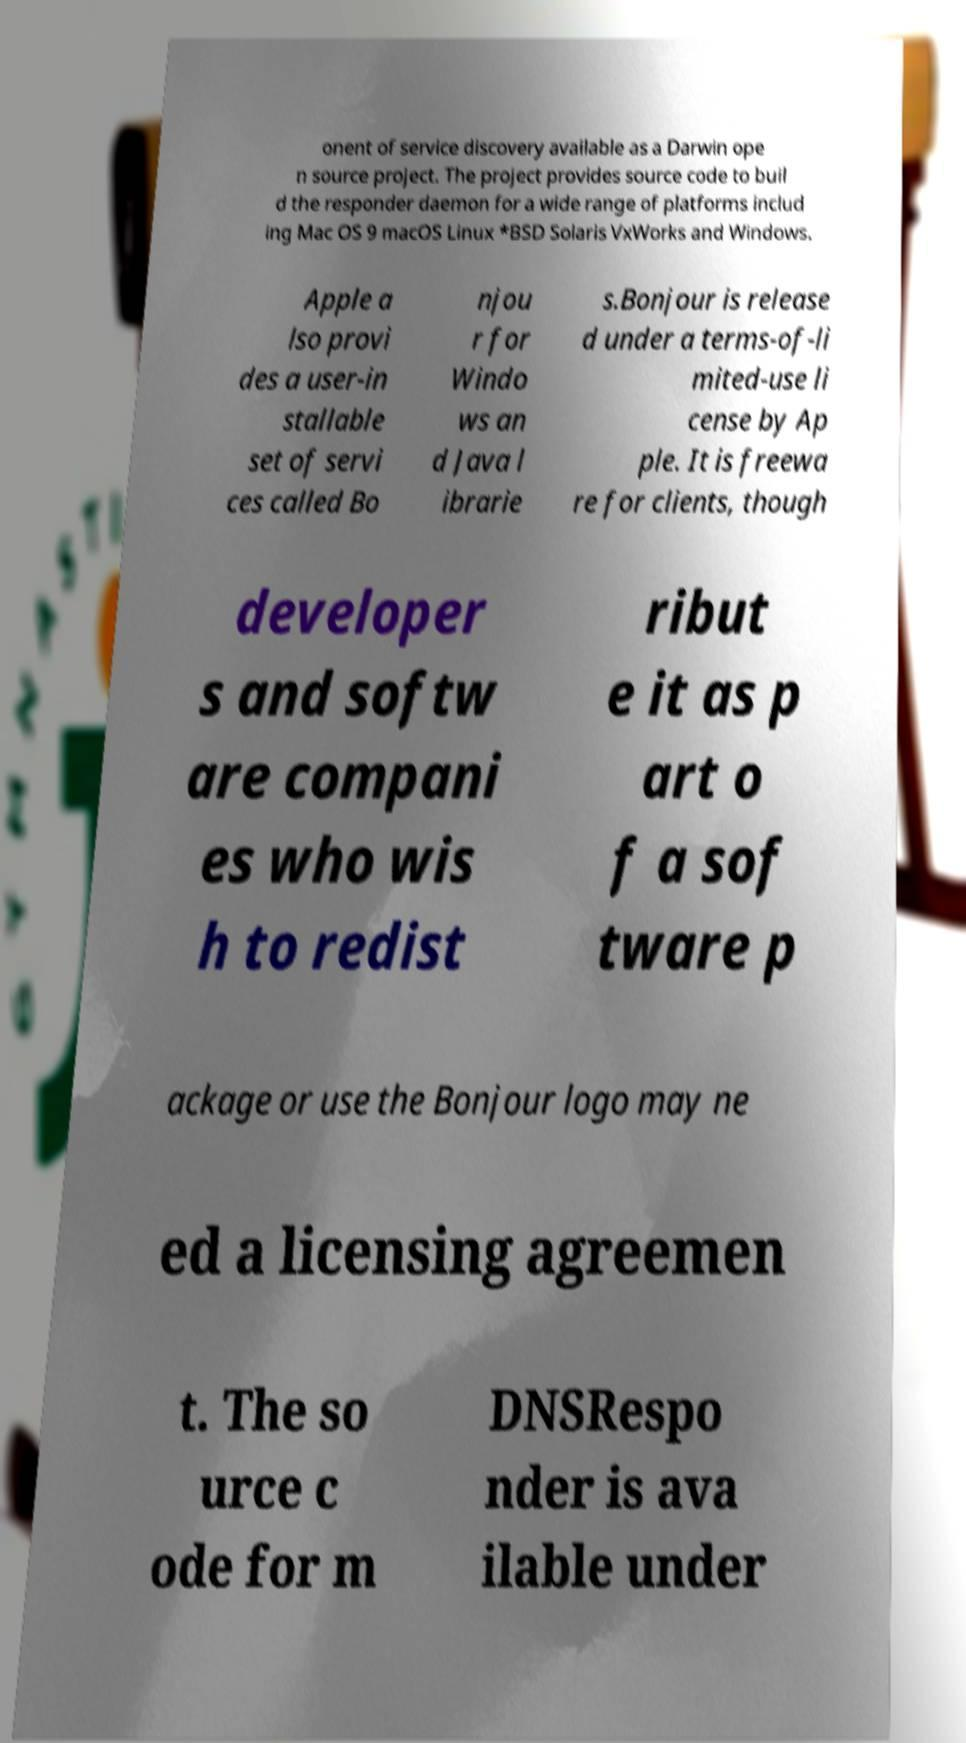Can you read and provide the text displayed in the image?This photo seems to have some interesting text. Can you extract and type it out for me? onent of service discovery available as a Darwin ope n source project. The project provides source code to buil d the responder daemon for a wide range of platforms includ ing Mac OS 9 macOS Linux *BSD Solaris VxWorks and Windows. Apple a lso provi des a user-in stallable set of servi ces called Bo njou r for Windo ws an d Java l ibrarie s.Bonjour is release d under a terms-of-li mited-use li cense by Ap ple. It is freewa re for clients, though developer s and softw are compani es who wis h to redist ribut e it as p art o f a sof tware p ackage or use the Bonjour logo may ne ed a licensing agreemen t. The so urce c ode for m DNSRespo nder is ava ilable under 